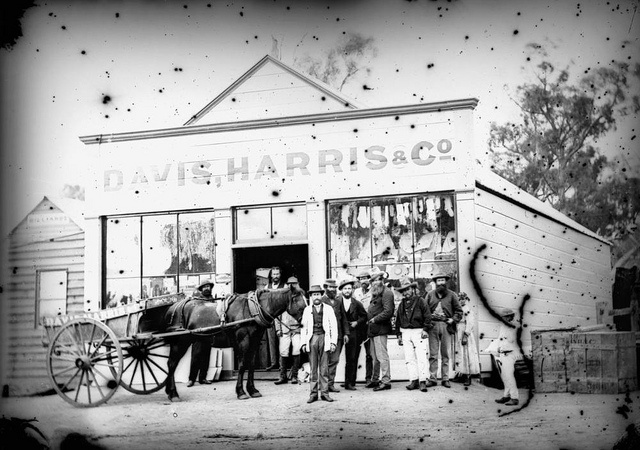Describe the objects in this image and their specific colors. I can see horse in black, gray, darkgray, and lightgray tones, people in black, white, gray, and darkgray tones, people in black, white, gray, and darkgray tones, people in black, gray, darkgray, and gainsboro tones, and people in black, gray, darkgray, and lightgray tones in this image. 